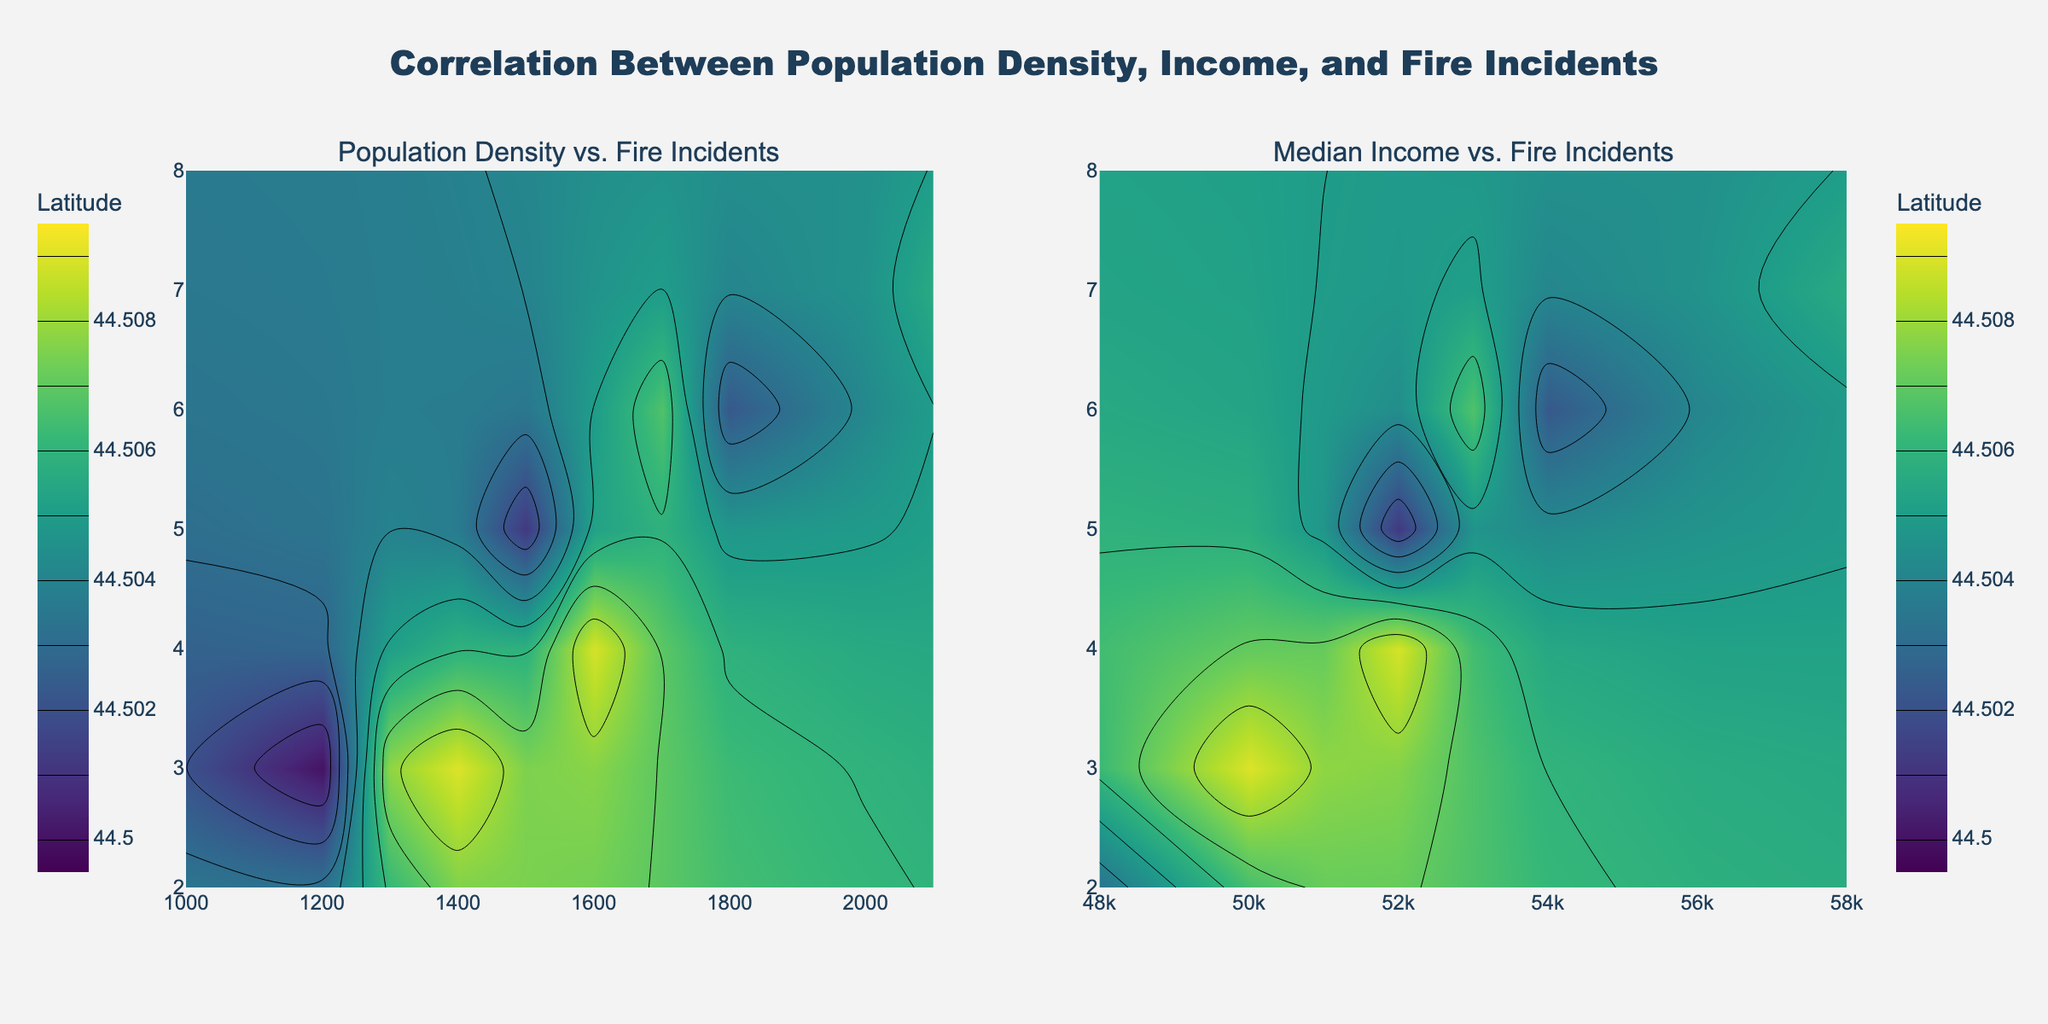What's the title of the figure? The title of a figure is typically located at the top center or specified in the layout description. In this figure, the title is "Correlation Between Population Density, Income, and Fire Incidents".
Answer: "Correlation Between Population Density, Income, and Fire Incidents" What does the first subplot represent? In the figure descriptions, the first subplot is titled "Population Density vs. Fire Incidents", which implies it depicts the relationship between population density and the number of fire incidents.
Answer: "Population Density vs. Fire Incidents" What is the color scale used in the contour plots, and what variable does it represent? The color scale in the contour plots is 'Viridis'. According to the hovertemplate and colorbar, this color scale represents the variable 'Latitude'.
Answer: 'Viridis', 'Latitude' Which axis represents the number of fire incidents, and what is its range? By examining the axis titles, the y-axis in both subplots represents the 'Number of Fire Incidents'. The range of this axis, based on data provided, spans from the minimum to the maximum number of fire incidents, which are 2 to 8.
Answer: y-axis, 2-8 Does higher population density correlate with more fire incidents? Refer to the first subplot "Population Density vs. Fire Incidents". Observing the direction and spread of the contours can indicate correlation. Higher population density generally overlaps with higher fire incidents, seen via denser contours in higher x values for density.
Answer: Yes Are areas with higher median income associated with more fire incidents compared to areas with lower median income? Refer to the second subplot "Median Income vs. Fire Incidents". Checking the color intensity and contour density indicates correlation. Higher median incomes generally overlap with more fire incidents, seen via clusters of denser contours in higher income ranges.
Answer: Yes What is the common visual element between both subplots, and why is it important? Both subplots use contour plots to illustrate the relationship between two variables (population density and median income) with the number of fire incidents, using latitude as a third dimension. This helps visualize how geographical variations interact with socio-economic factors in affecting fire incidents.
Answer: Contour plots, Latitude In the 'Median Income vs. Fire Incidents' subplot, what median income range seems to align most with fire incidents at latitude 44.5056? Observing the colors and contours, identify the latitude color for 44.5056 and check corresponding median income ranges. The densest contour clusters around $58000 income, aligning most with that latitude.
Answer: $58000 Which variable shows a denser range of contours in relation to the number of fire incidents: population density or median income? Compare the contour densities in both subplots. The subplot with population density as the x-axis shows more tightly packed contours around higher fire incidents than the median income subplot does, indicating a denser range.
Answer: Population Density 